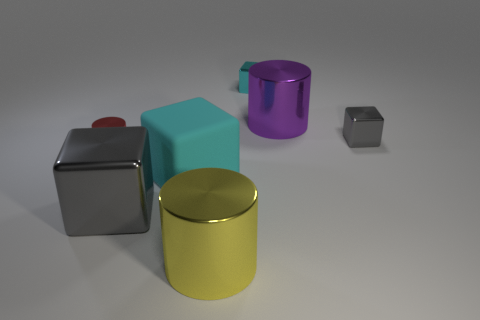Add 2 tiny metal blocks. How many objects exist? 9 Subtract all cyan blocks. How many blocks are left? 2 Subtract all shiny cubes. How many cubes are left? 1 Subtract 0 green cubes. How many objects are left? 7 Subtract all blocks. How many objects are left? 3 Subtract 1 cylinders. How many cylinders are left? 2 Subtract all brown cylinders. Subtract all blue spheres. How many cylinders are left? 3 Subtract all brown balls. How many gray cubes are left? 2 Subtract all gray metallic cubes. Subtract all large cyan matte things. How many objects are left? 4 Add 2 metallic objects. How many metallic objects are left? 8 